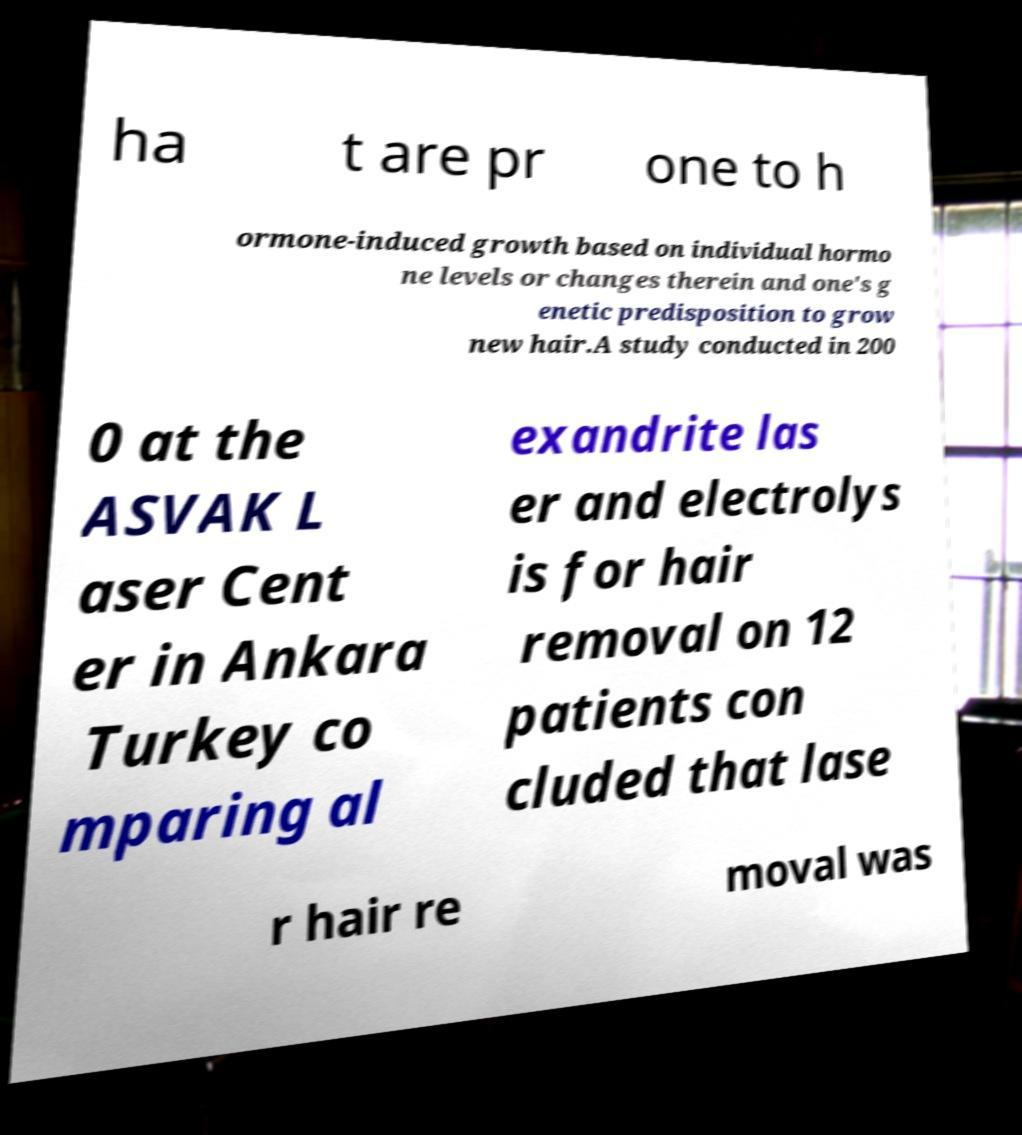I need the written content from this picture converted into text. Can you do that? ha t are pr one to h ormone-induced growth based on individual hormo ne levels or changes therein and one's g enetic predisposition to grow new hair.A study conducted in 200 0 at the ASVAK L aser Cent er in Ankara Turkey co mparing al exandrite las er and electrolys is for hair removal on 12 patients con cluded that lase r hair re moval was 